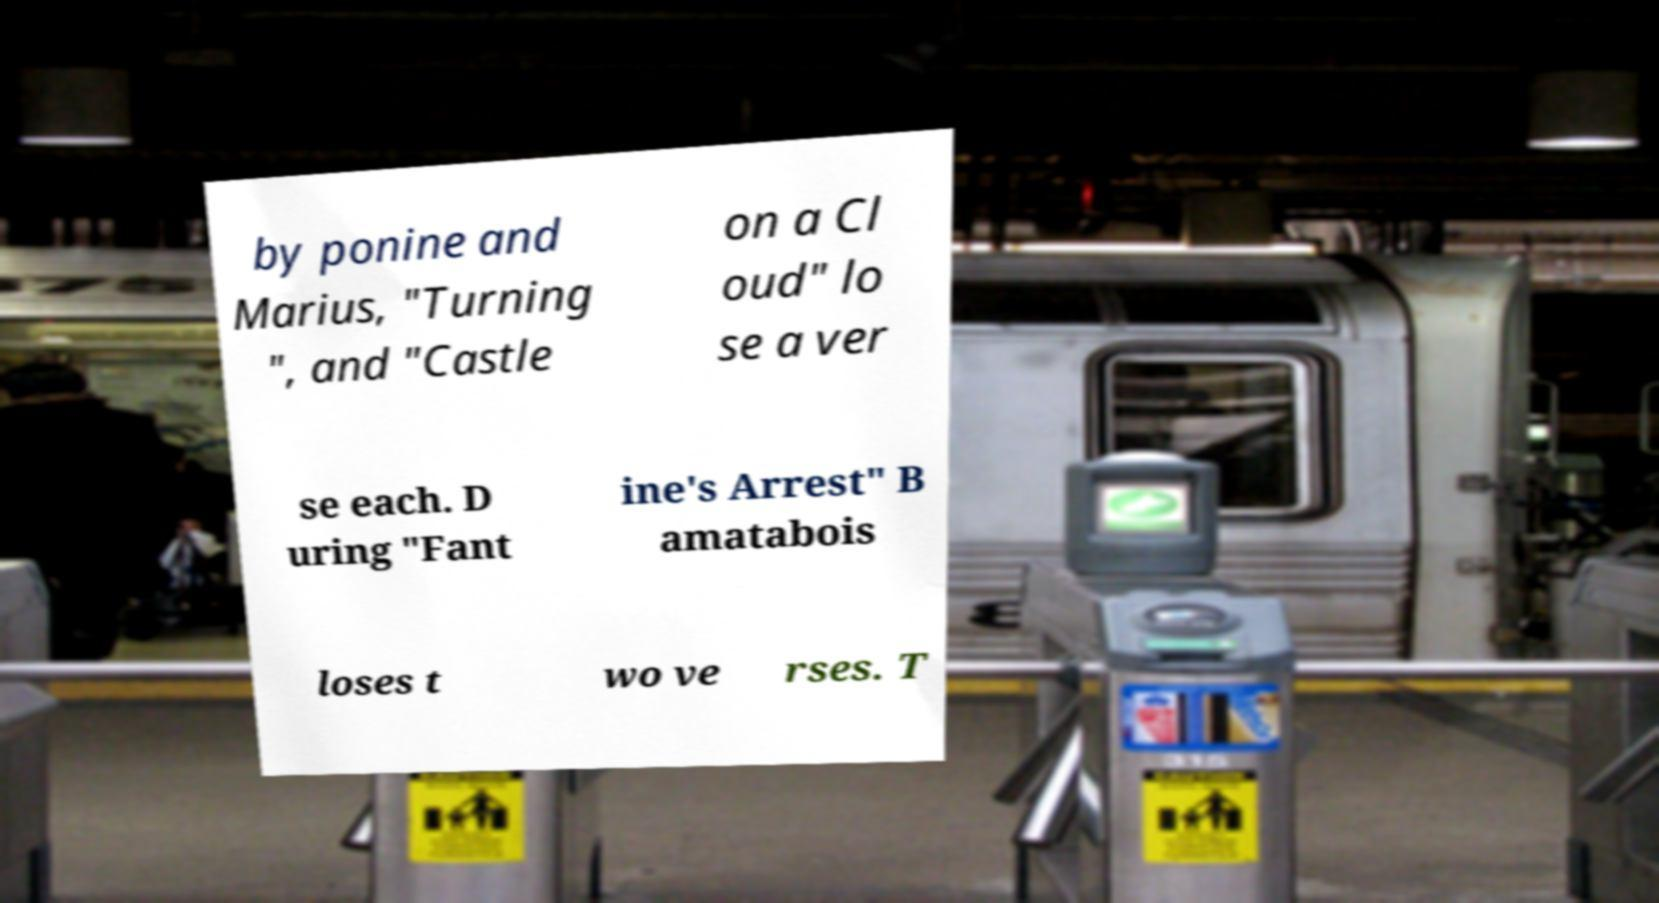I need the written content from this picture converted into text. Can you do that? by ponine and Marius, "Turning ", and "Castle on a Cl oud" lo se a ver se each. D uring "Fant ine's Arrest" B amatabois loses t wo ve rses. T 